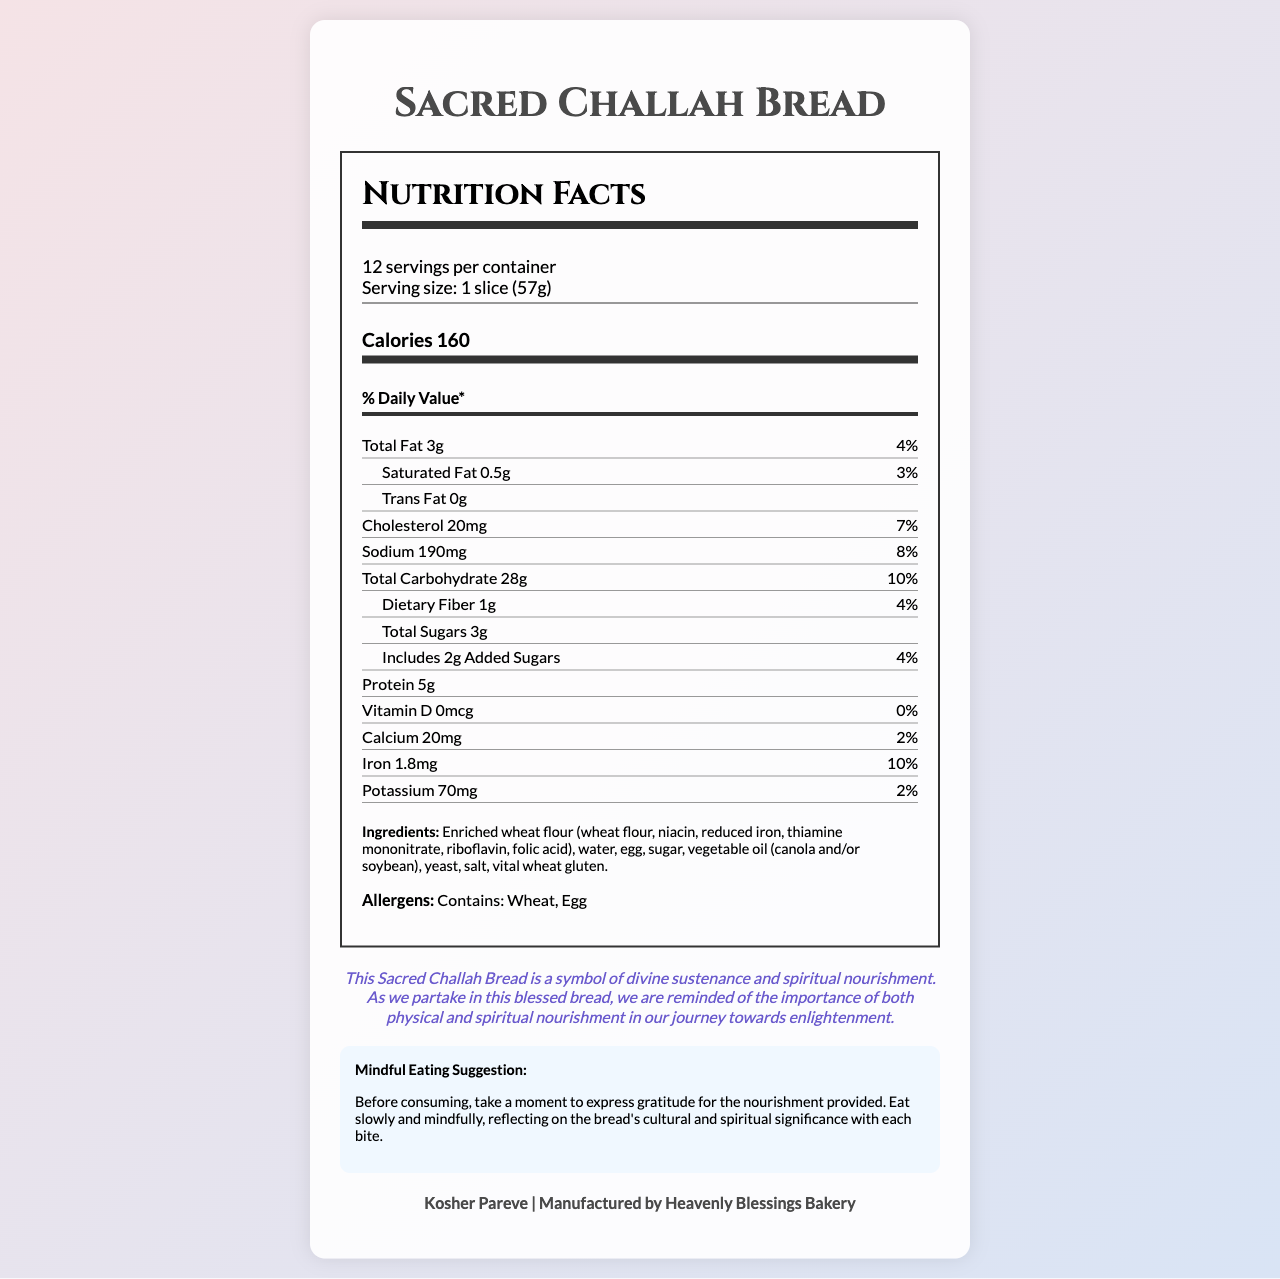what is the serving size? The serving size is explicitly stated as 1 slice (57g) in the document.
Answer: 1 slice (57g) how many calories are in one serving? The calorie count for one serving is listed as 160 calories.
Answer: 160 calories which two ingredients are the major allergens? The allergens section explicitly states that this bread contains wheat and egg.
Answer: Wheat, Egg is the bread suitable for vegans? The bread contains eggs, which makes it unsuitable for vegans.
Answer: No what is the daily value percentage for total fat? The daily value for total fat is listed as 4% in the document.
Answer: 4% how many servings are there per container? The document lists that there are 12 servings per container.
Answer: 12 how much sodium is in one serving? The amount of sodium per serving is stated as 190mg.
Answer: 190mg what is the main spiritual message associated with this bread? The spiritual significance section describes the bread as a symbol of divine sustenance and spiritual nourishment.
Answer: A symbol of divine sustenance and spiritual nourishment what is the protein content per serving? The protein content per serving is listed as 5g.
Answer: 5g how is the bread certified? A. Organic B. Kosher Pareve C. Non-GMO The certification section states that the bread is Kosher Pareve.
Answer: B. Kosher Pareve which of the following nutrients has the lowest daily value percentage? A. Vitamin D B. Calcium C. Iron D. Potassium Vitamin D has a daily value percentage of 0%, which is lower than the daily values for Calcium (2%), Iron (10%), and Potassium (2%).
Answer: A. Vitamin D how many grams of dietary fiber does one serving contain? A. 0g B. 1g C. 2g D. 3g The document lists that one serving contains 1g of dietary fiber.
Answer: B. 1g does the bread contain any added sugars? The bread includes 2g of added sugars per serving.
Answer: Yes describe the mindful eating suggestion for this bread The mindful eating suggestion emphasizes expressing gratitude before consuming, and eating slowly and mindfully, reflecting on the bread's cultural and spiritual significance.
Answer: Express gratitude, eat slowly and mindfully reflecting on the bread's cultural and spiritual significance. how many calories come from fat in one serving? The document does not provide specific information on how many calories come from fat.
Answer: Not enough information 